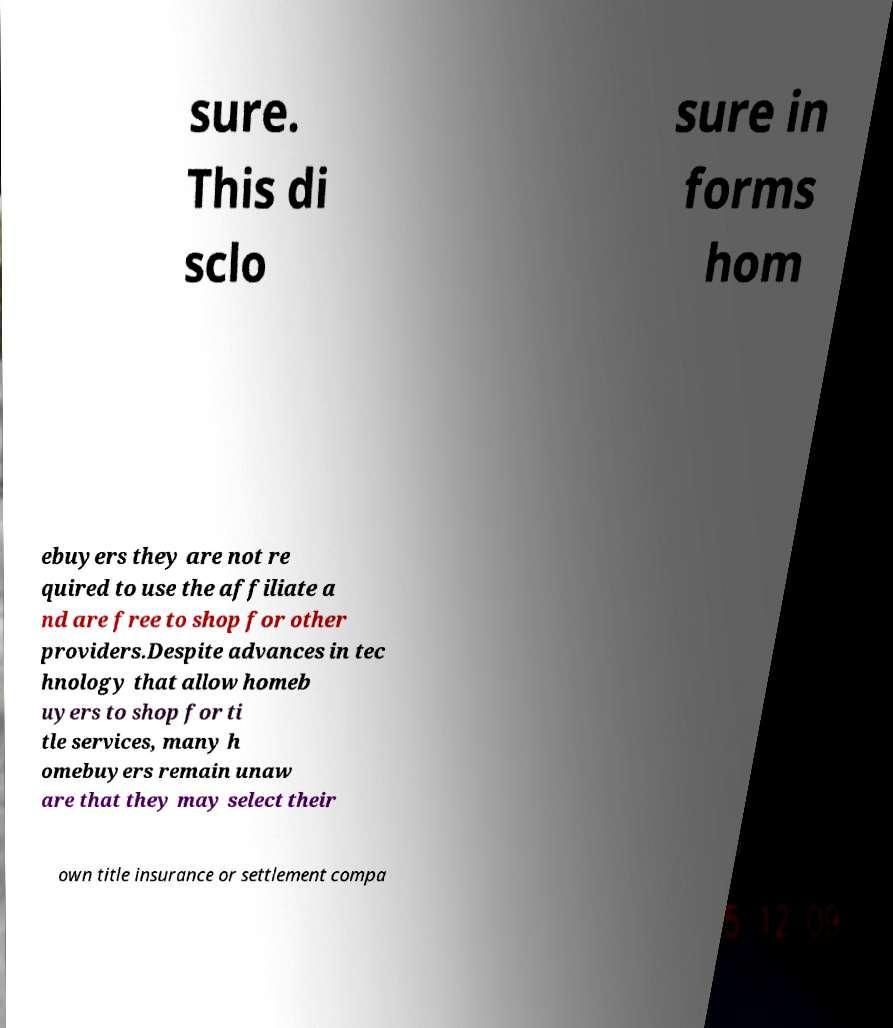I need the written content from this picture converted into text. Can you do that? sure. This di sclo sure in forms hom ebuyers they are not re quired to use the affiliate a nd are free to shop for other providers.Despite advances in tec hnology that allow homeb uyers to shop for ti tle services, many h omebuyers remain unaw are that they may select their own title insurance or settlement compa 